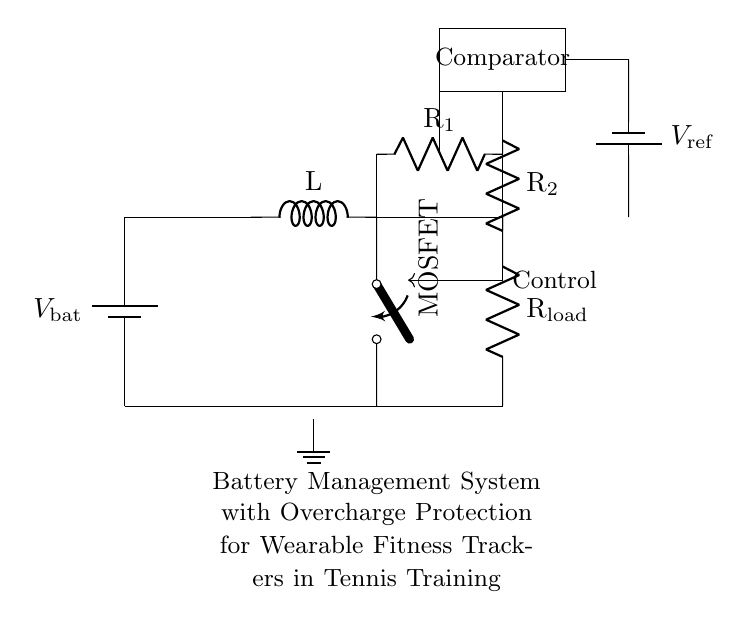What is the component type of the primary power source? The primary power source in the circuit is represented as a battery, specifically indicated with the symbol for a battery in the diagram.
Answer: Battery What does the MOSFET control in this circuit? The MOSFET acts as a switch that controls the charging circuit, allowing or stopping the charging process based on the control signal provided from the comparator.
Answer: Charging What purpose does the comparator serve? The comparator is used to compare the voltage across the load and the reference voltage to determine whether to turn off the MOSFET and prevent overcharging the battery.
Answer: Overcharge protection What are the resistors labeled R1 and R2 used for? R1 and R2 form a voltage divider that helps the comparator to determine if the battery voltage exceeds the safe limit for charging, triggering the MOSFET to switch off.
Answer: Voltage dividing How is the ground connected in this circuit? The ground is depicted as a single point connecting to the lower side of the circuit, providing a common reference point for all the components, ensuring proper operation of the circuit.
Answer: Lower side What is the reference voltage sourced from? The reference voltage is sourced from a separate battery indicated in the circuit, which provides a stable voltage level that the comparator uses for comparison against the voltage across R1 and R2.
Answer: Battery 